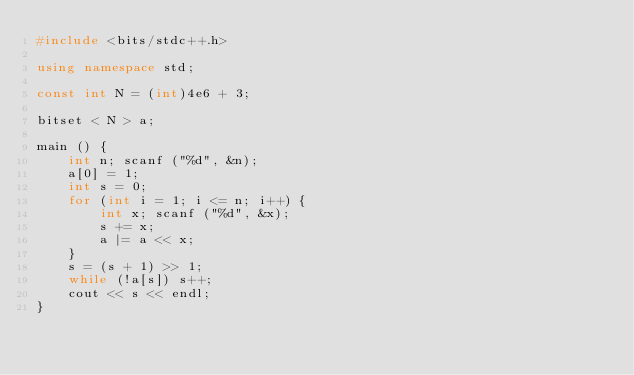Convert code to text. <code><loc_0><loc_0><loc_500><loc_500><_C++_>#include <bits/stdc++.h>

using namespace std;

const int N = (int)4e6 + 3;

bitset < N > a;

main () {
    int n; scanf ("%d", &n);
    a[0] = 1;
    int s = 0;
    for (int i = 1; i <= n; i++) {
        int x; scanf ("%d", &x);
        s += x;
        a |= a << x;
    }
    s = (s + 1) >> 1;
    while (!a[s]) s++;
    cout << s << endl;
}
</code> 